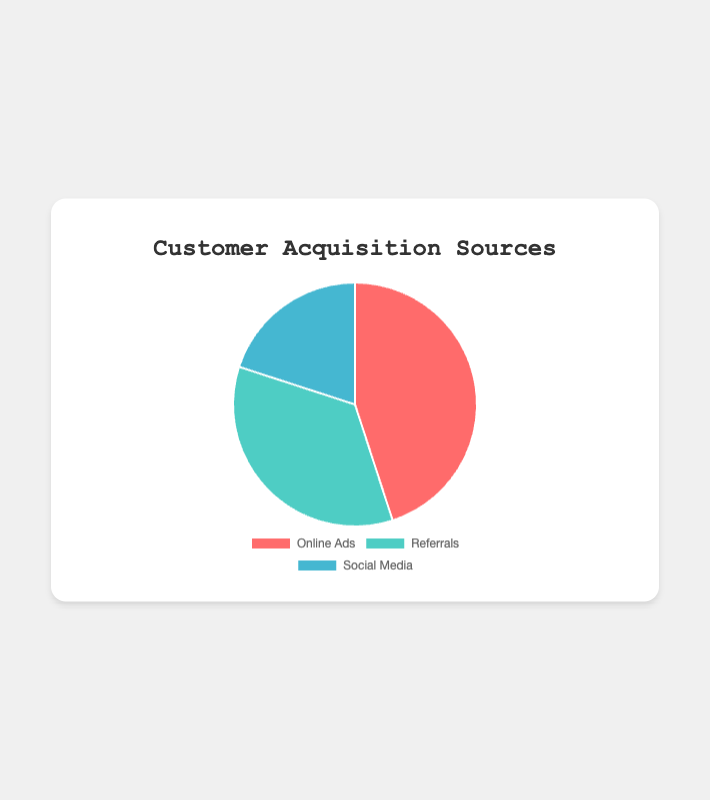What percentage of customers come from Online Ads? To find this, look at the segment labeled "Online Ads" in the pie chart. The corresponding percentage is given as 45%.
Answer: 45% Which customer acquisition source is the smallest? Compare the percentages of each segment. The smallest percentage is 20%, which corresponds to the "Social Media" segment.
Answer: Social Media How much larger is the percentage from Referrals compared to Social Media? Subtract the percentage of "Social Media" from the percentage of "Referrals". This is 35% - 20% = 15%.
Answer: 15% What is the combined percentage of customers from Referrals and Social Media? Add the percentage of "Referrals" and "Social Media". This is 35% + 20% = 55%.
Answer: 55% Does the percentage from Online Ads exceed the combined percentage from Referrals and Social Media? The percentage from Online Ads is 45%. The combined percentage from Referrals and Social Media is 55%. Since 45% is less than 55%, the answer is no.
Answer: No What color represents the Social Media segment in the chart? Visually look at the segment labeled "Social Media" in the pie chart. The segment is blue.
Answer: Blue If we were to increase the percentage from Online Ads by 5%, what would the new percentage be? Add 5% to the current percentage for Online Ads. This is 45% + 5% = 50%.
Answer: 50% What is the difference between the largest and smallest customer acquisition sources? Identify the largest and smallest percentages in the pie chart. The largest is 45% (Online Ads) and the smallest is 20% (Social Media). The difference is 45% - 20% = 25%.
Answer: 25% Which two sources together account for less than half of the total customer acquisition sources? Check combinations of percentages. "Referrals" (35%) and "Social Media" (20%) together make 55%, which is more than half. However, "Online Ads" (45%) and "Social Media" (20%) make 45% + 20% = 65%, which is also more than half. The only combination that sums to less than half is "Referrals" (35%) alone.
Answer: Referrals and none 